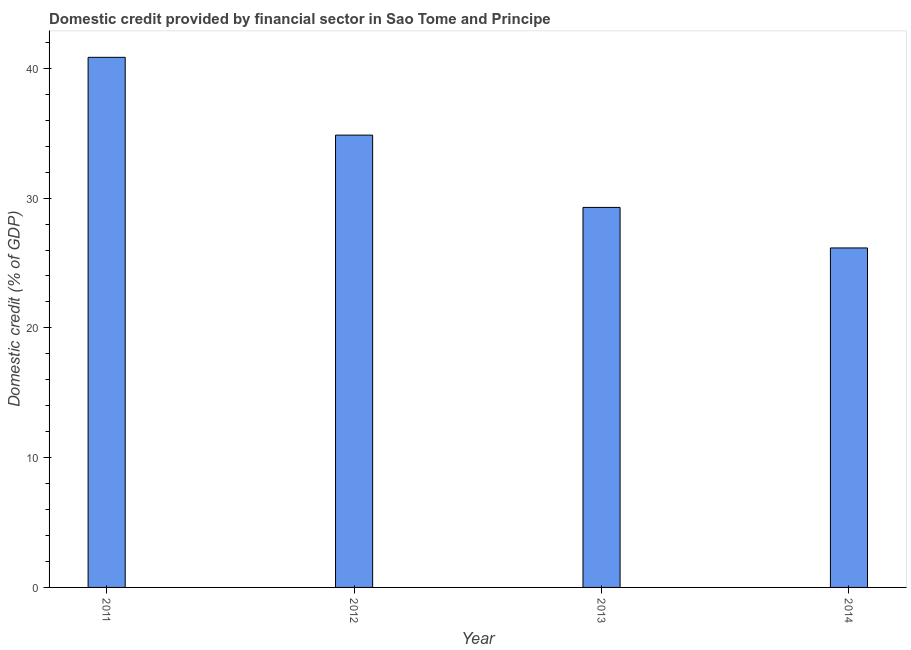Does the graph contain grids?
Your answer should be very brief. No. What is the title of the graph?
Keep it short and to the point. Domestic credit provided by financial sector in Sao Tome and Principe. What is the label or title of the X-axis?
Make the answer very short. Year. What is the label or title of the Y-axis?
Offer a very short reply. Domestic credit (% of GDP). What is the domestic credit provided by financial sector in 2011?
Keep it short and to the point. 40.85. Across all years, what is the maximum domestic credit provided by financial sector?
Offer a very short reply. 40.85. Across all years, what is the minimum domestic credit provided by financial sector?
Provide a succinct answer. 26.16. In which year was the domestic credit provided by financial sector minimum?
Make the answer very short. 2014. What is the sum of the domestic credit provided by financial sector?
Ensure brevity in your answer.  131.15. What is the difference between the domestic credit provided by financial sector in 2011 and 2013?
Give a very brief answer. 11.57. What is the average domestic credit provided by financial sector per year?
Make the answer very short. 32.79. What is the median domestic credit provided by financial sector?
Offer a very short reply. 32.07. What is the ratio of the domestic credit provided by financial sector in 2013 to that in 2014?
Keep it short and to the point. 1.12. Is the difference between the domestic credit provided by financial sector in 2013 and 2014 greater than the difference between any two years?
Offer a terse response. No. What is the difference between the highest and the second highest domestic credit provided by financial sector?
Your response must be concise. 6. Is the sum of the domestic credit provided by financial sector in 2011 and 2012 greater than the maximum domestic credit provided by financial sector across all years?
Provide a succinct answer. Yes. What is the difference between the highest and the lowest domestic credit provided by financial sector?
Make the answer very short. 14.69. How many bars are there?
Make the answer very short. 4. What is the difference between two consecutive major ticks on the Y-axis?
Your answer should be very brief. 10. What is the Domestic credit (% of GDP) of 2011?
Your answer should be compact. 40.85. What is the Domestic credit (% of GDP) in 2012?
Offer a very short reply. 34.86. What is the Domestic credit (% of GDP) in 2013?
Keep it short and to the point. 29.28. What is the Domestic credit (% of GDP) in 2014?
Give a very brief answer. 26.16. What is the difference between the Domestic credit (% of GDP) in 2011 and 2012?
Provide a short and direct response. 5.99. What is the difference between the Domestic credit (% of GDP) in 2011 and 2013?
Provide a short and direct response. 11.57. What is the difference between the Domestic credit (% of GDP) in 2011 and 2014?
Make the answer very short. 14.69. What is the difference between the Domestic credit (% of GDP) in 2012 and 2013?
Offer a very short reply. 5.57. What is the difference between the Domestic credit (% of GDP) in 2012 and 2014?
Ensure brevity in your answer.  8.69. What is the difference between the Domestic credit (% of GDP) in 2013 and 2014?
Offer a very short reply. 3.12. What is the ratio of the Domestic credit (% of GDP) in 2011 to that in 2012?
Your answer should be compact. 1.17. What is the ratio of the Domestic credit (% of GDP) in 2011 to that in 2013?
Ensure brevity in your answer.  1.4. What is the ratio of the Domestic credit (% of GDP) in 2011 to that in 2014?
Provide a short and direct response. 1.56. What is the ratio of the Domestic credit (% of GDP) in 2012 to that in 2013?
Make the answer very short. 1.19. What is the ratio of the Domestic credit (% of GDP) in 2012 to that in 2014?
Give a very brief answer. 1.33. What is the ratio of the Domestic credit (% of GDP) in 2013 to that in 2014?
Your response must be concise. 1.12. 